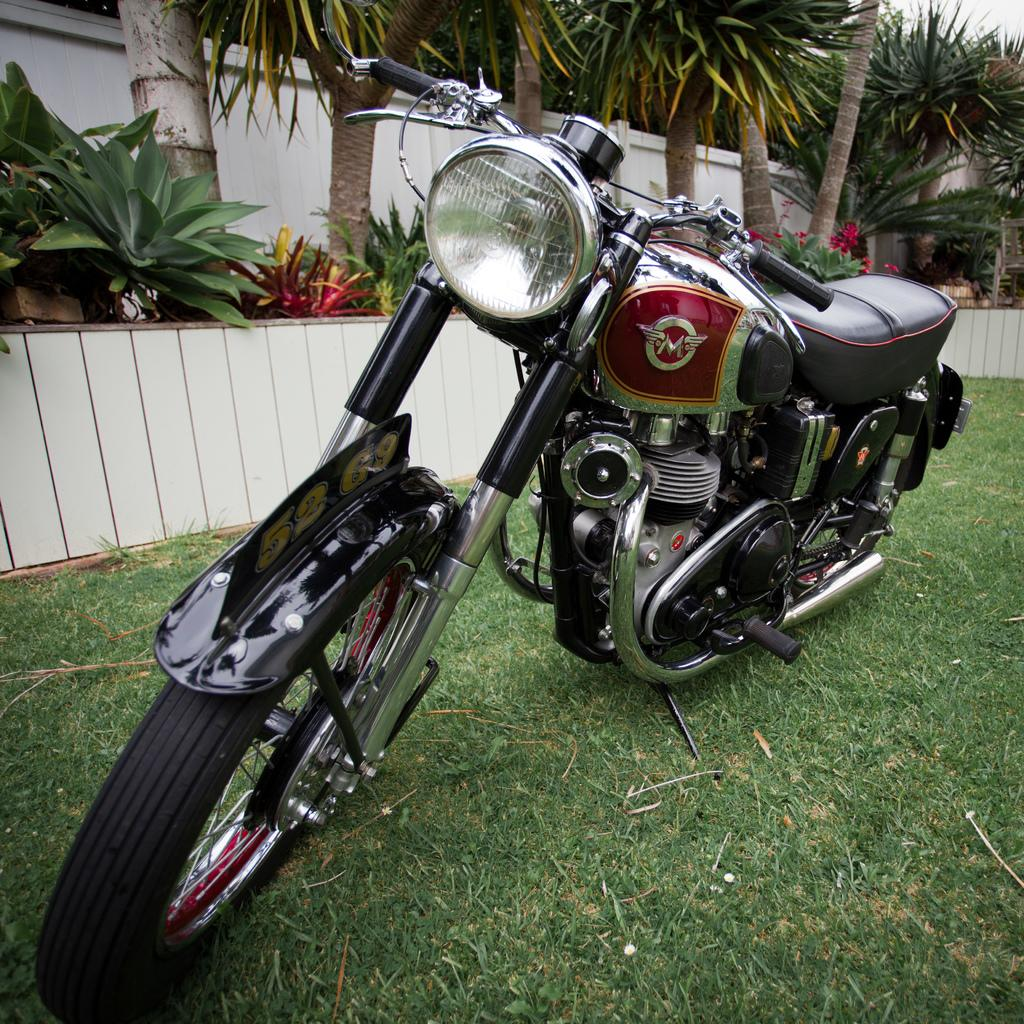What is the main object in the image? There is a bike in the image. Where is the bike located? The bike is parked on a grass surface. What type of vegetation can be seen in the image? There are plants and trees visible in the image. What type of bait is being used to catch fish in the image? There is no mention of fishing or bait in the image; it features a bike parked on a grass surface with plants and trees visible. How many children are playing near the bike in the image? There is no mention of children in the image; it only features a bike parked on a grass surface with plants and trees visible. 